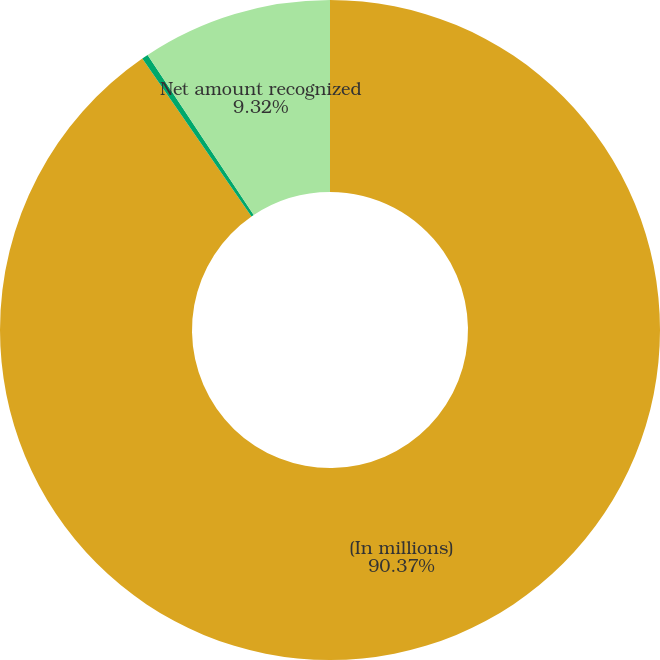Convert chart. <chart><loc_0><loc_0><loc_500><loc_500><pie_chart><fcel>(In millions)<fcel>Net actuarial (gain) loss<fcel>Net amount recognized<nl><fcel>90.37%<fcel>0.31%<fcel>9.32%<nl></chart> 